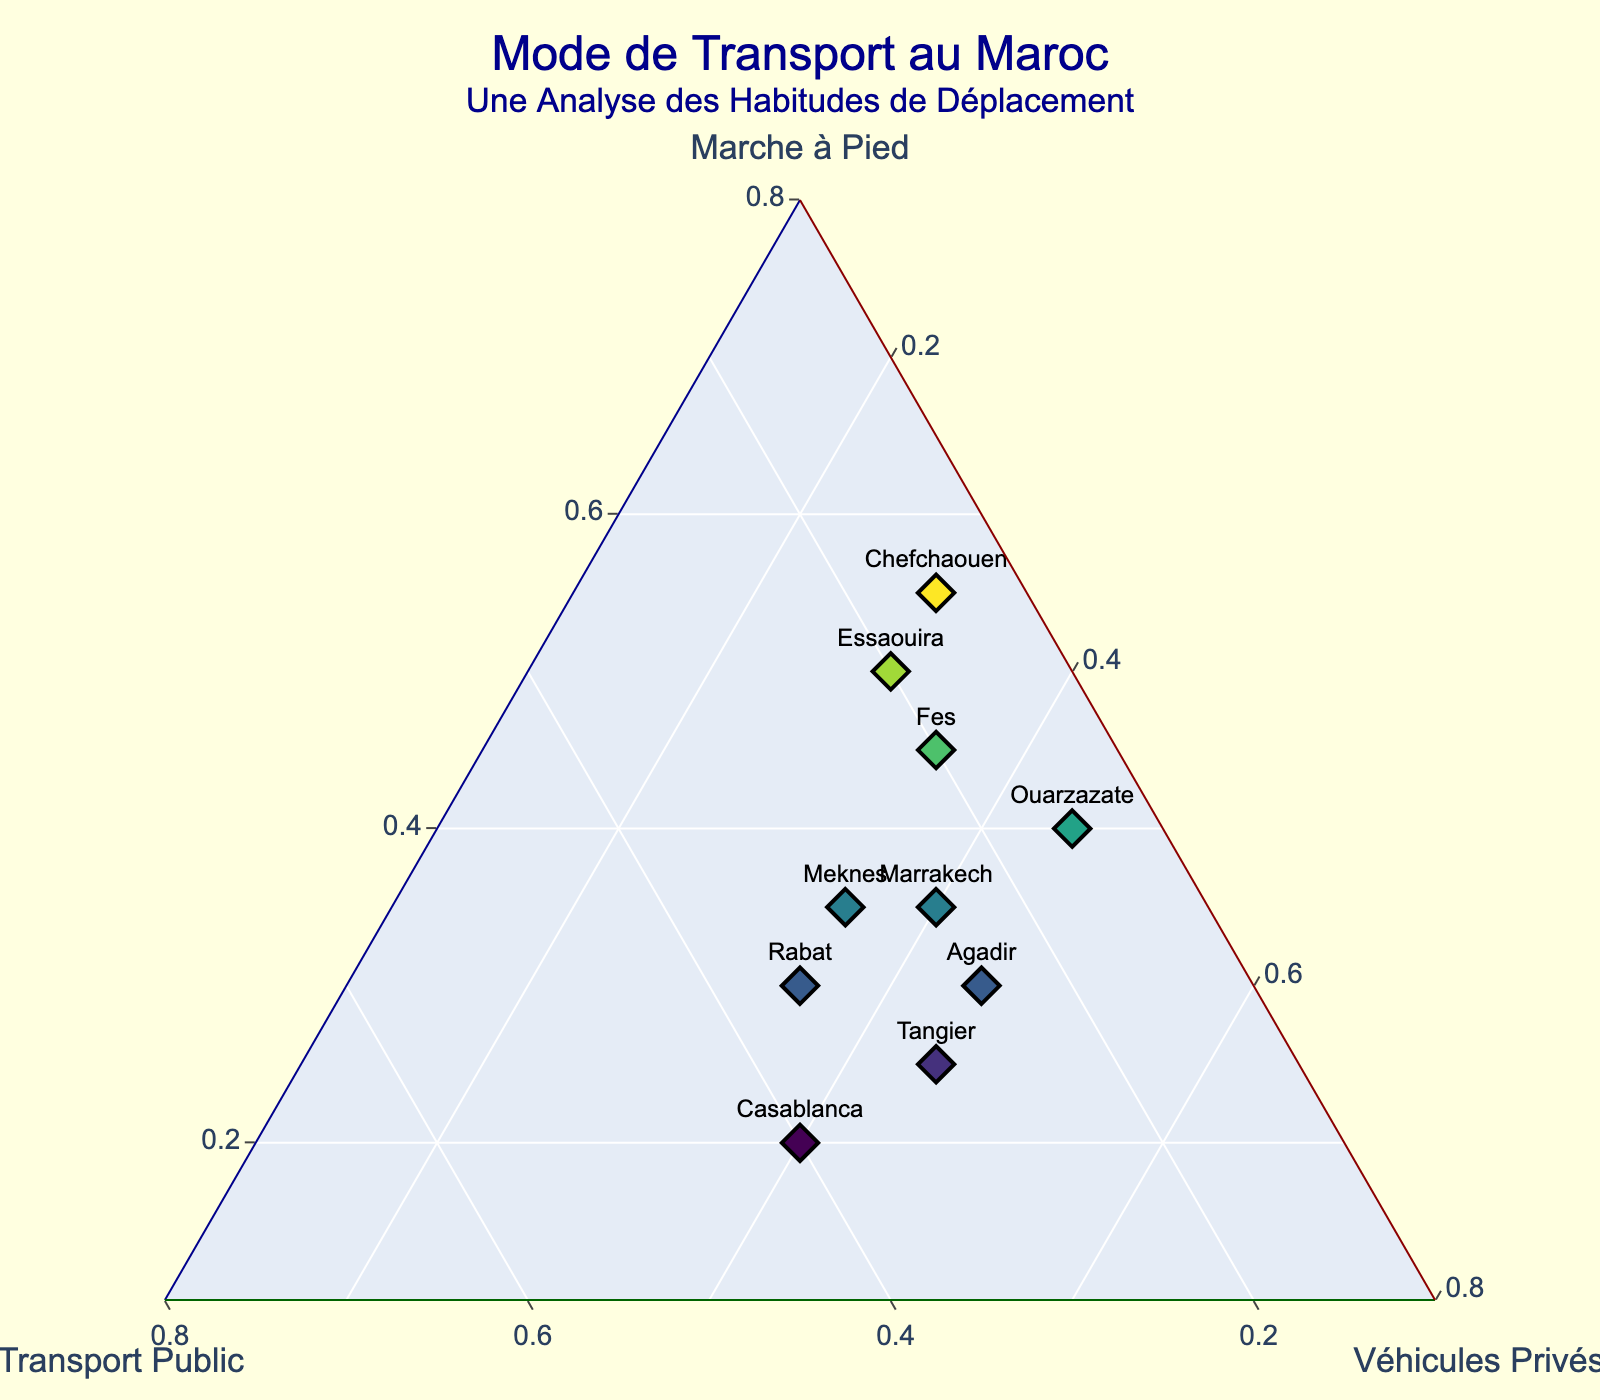What is the maximum percentage for walking among all locations? By checking the data points along the 'Marche à Pied' axis and identifying the highest value, we can see that Chefchaouen has the highest proportion dedicated to walking at 0.55 (or 55%).
Answer: 55% Which city has the most balanced time distribution among walking, public transit, and private vehicles? To find the most balanced distribution, look for the data point closest to the center of the ternary plot. Rabat is closest to the center with 30% walking, 35% public transit, and 35% private vehicles.
Answer: Rabat How many cities have a higher proportion of walking compared to public transit? By comparing the values of walking and public transit for each city, Chefchaouen, Fes, Essaouira, and Ouarzazate have a higher walking proportion than public transit. Therefore, there are four cities.
Answer: 4 Which town uses private vehicles the least? By identifying the lowest point along the 'Véhicules Privés' axis, Chefchaouen has the smallest proportion with 0.30 (or 30%).
Answer: Chefchaouen Which location has the greatest reliance on public transit? By checking the data points along the 'Transport Public' axis, Casablanca has the highest proportion of public transit with 0.40 (or 40%).
Answer: Casablanca What is the sum of the normalized proportions of public transit for all locations? Summing up the normalized public transit proportions: 0.25 (Marrakech) + 0.40 (Casablanca) + 0.20 (Fes) + 0.35 (Rabat) + 0.15 (Chefchaouen) + 0.30 (Tangier) + 0.20 (Essaouira) + 0.25 (Agadir) + 0.15 (Ouarzazate) + 0.30 (Meknes) = 2.55
Answer: 2.55 Which city is the furthest from using private vehicles as the primary mode of transportation? To answer this, look for the city with the smallest value for private vehicles. Chefchaouen has the smallest percentage for private vehicles, making it furthest from using private vehicles as the primary mode.
Answer: Chefchaouen If you were to take public transportation in Tangier, what would be unique about its representation on the plot? Check the public transit percentage for Tangier. Unlike any other city, the proportion of public transit (0.30) is exactly between the lowest and highest proportions among all cities, making it balanced in a unique way.
Answer: Balanced at 30% Which two cities have identical proportions for private vehicles? By comparing the private vehicle proportions across locations, Marrakech and Casablanca both have 0.40 for private vehicles.
Answer: Marrakech, Casablanca 